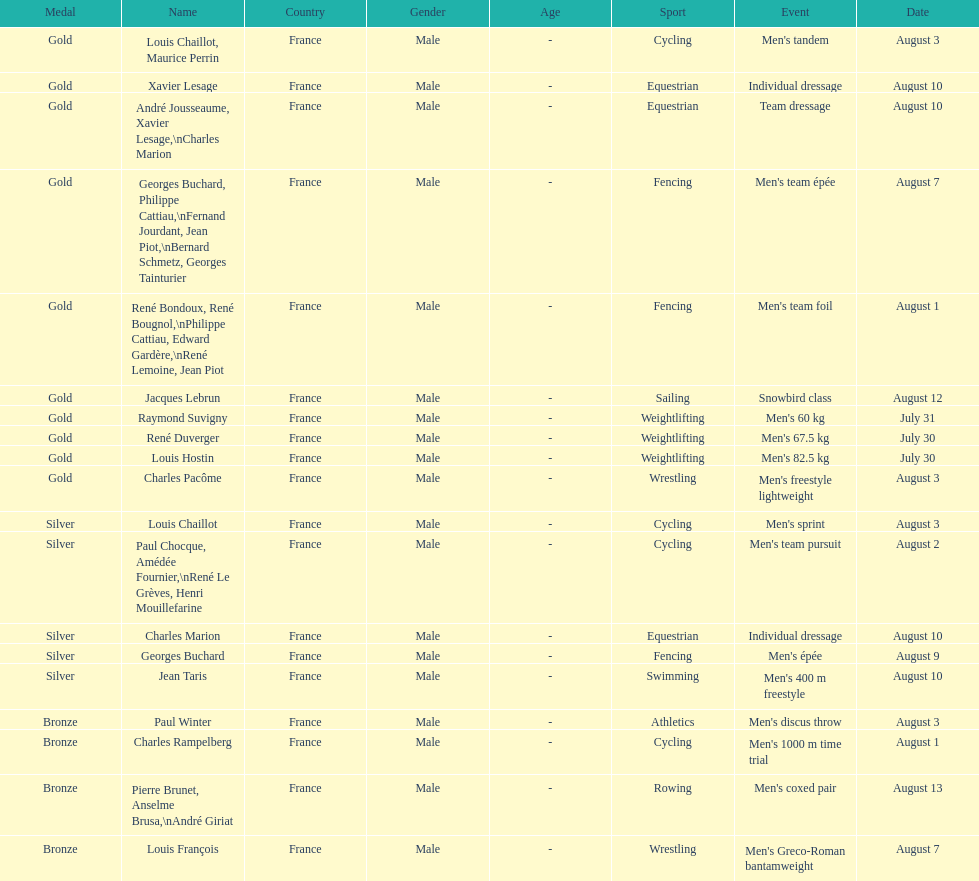What sport is listed first? Cycling. 